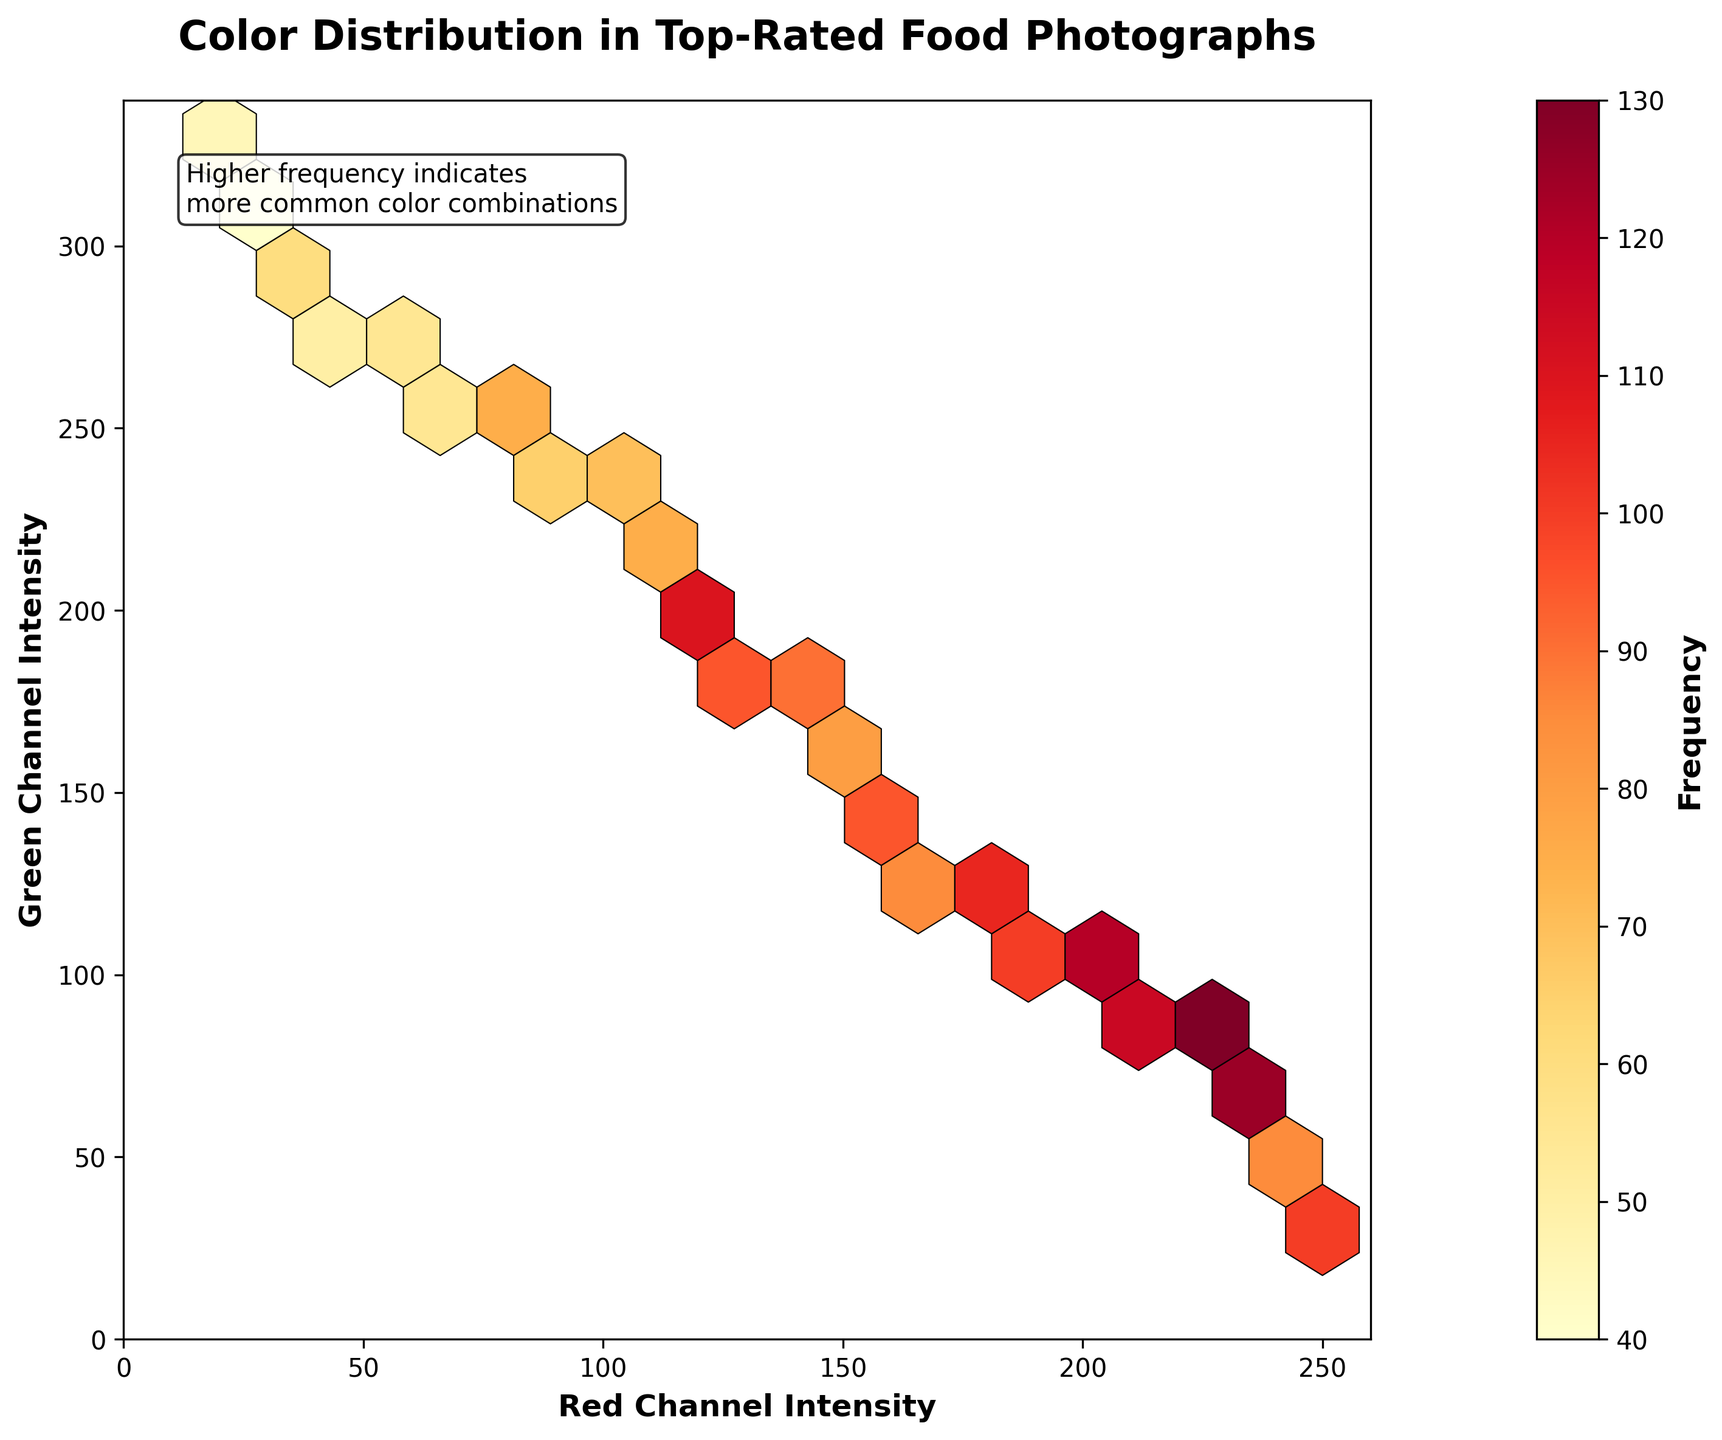What is the title of the plot? The title can be found at the top of the plot and describes the main subject of the visualization. In this case, it helps us understand the context of the color distribution analysis.
Answer: Color Distribution in Top-Rated Food Photographs What does the color bar represent and where is it located? The color bar is located on the right side of the plot and represents the frequency of occurrences for different color combinations in the food photographs.
Answer: Frequency What are the ranges of the x and y axes? The range of the x-axis, labeled 'Red Channel Intensity', is from 0 to 260. The range of the y-axis, labeled 'Green Channel Intensity', is from 0 to 340. These ranges can be observed by looking at the axis labels and tick marks.
Answer: x-axis: 0-260, y-axis: 0-340 What is the color with the highest frequency based on the hexbin plot? Look for the darkest hexagon in the plot, as the color intensity represents frequency. The darkest hexagon is located at coordinates (200, 100).
Answer: Red: 200, Green: 100 Which hexagon on the plot has the highest intensity within the red channel intensity of 240 to 250? Locate hexagons within the specified x-axis range (240 to 250) and find the one with the darkest shade, indicating the highest frequency. The hexagon at (240, 50) holds the highest intensity in this range.
Answer: (240, 50) How many hexagons are shown in the figure? The number of hexagons can be counted by observing the cells distributed across the plot. Each hexagon represents a combination of data points. By counting, we find there are 24 hexagons.
Answer: 24 What is the overall trend in color distribution regarding frequency? By assessing the overall distribution and intensity of the hexagons, we can see that certain color combinations, especially around (200, 100), (220, 80), and (230, 60), appear more frequently, suggesting that specific combinations of red and green intensities are more common in top-rated food photographs.
Answer: Colors around (200, 100), (220, 80), and (230, 60) are more frequent Among the hexagons located at higher green channel intensities (greater than 200), which has the lowest frequency? Focus on the upper part of the plot where the green channel intensities are above 200, and identify the least dark, or lightest, hexagon. The hexagon at (20, 330) appears the lightest.
Answer: (20, 330) Compare the number of high-frequency hexagons (darkest shades) to low-frequency hexagons (lightest shades). What does it tell you about the distribution of popular color combinations? Count the darkest and lightest hexagons. We find that high-frequency hexagons are fewer than low-frequency ones, indicating that only a few specific color combinations are very popular, while most colors appear less frequently in top-rated food photographs.
Answer: Fewer high-frequency hexagons than low-frequency ones 